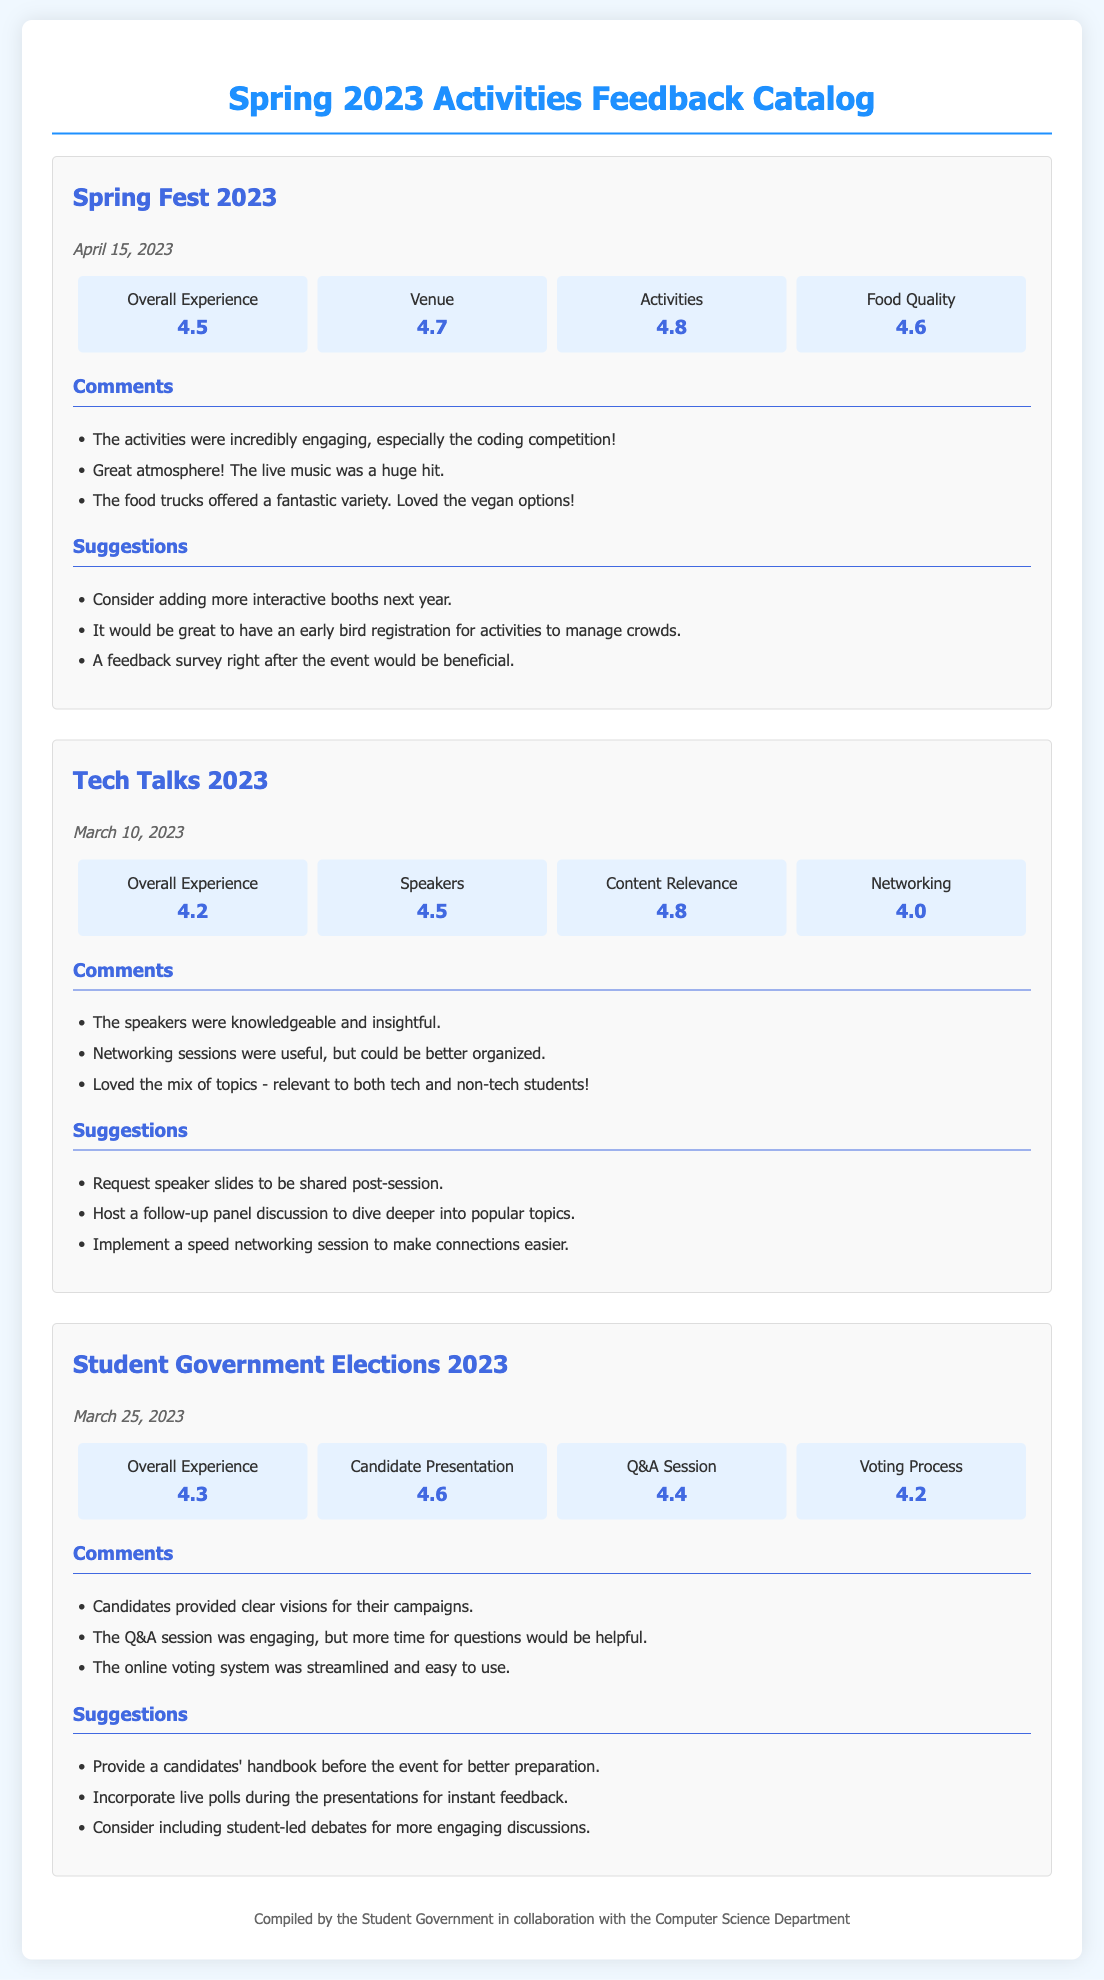What is the date of Spring Fest 2023? Spring Fest 2023 is scheduled for April 15, 2023, as indicated in the document.
Answer: April 15, 2023 What was the overall rating for Tech Talks 2023? The overall rating for Tech Talks 2023 is 4.2, which is listed in the ratings section of the document.
Answer: 4.2 How did attendees rate the candidate presentations during the Student Government Elections 2023? Candidate presentations were rated 4.6, found in the ratings section of the Student Government Elections.
Answer: 4.6 What is one suggestion made for the Tech Talks 2023 event? One suggestion from the feedback for Tech Talks 2023 is to host a follow-up panel discussion to dive deeper into popular topics, listed in the suggestions section.
Answer: Host a follow-up panel discussion Which activity received the highest rating for food quality? Spring Fest 2023 received a food quality rating of 4.6, which is the highest among the events in the document.
Answer: 4.6 What was a common comment about the food trucks at Spring Fest 2023? Attendees commented about the great variety of food trucks, specifically mentioning the vegan options, found in the comments area.
Answer: Loved the vegan options What event was held on March 25, 2023? The event held on March 25, 2023, was the Student Government Elections 2023, which is mentioned in the event date section.
Answer: Student Government Elections 2023 How did the participants rate networking opportunities at Tech Talks 2023? Networking was rated 4.0, which is mentioned in the ratings for Tech Talks.
Answer: 4.0 